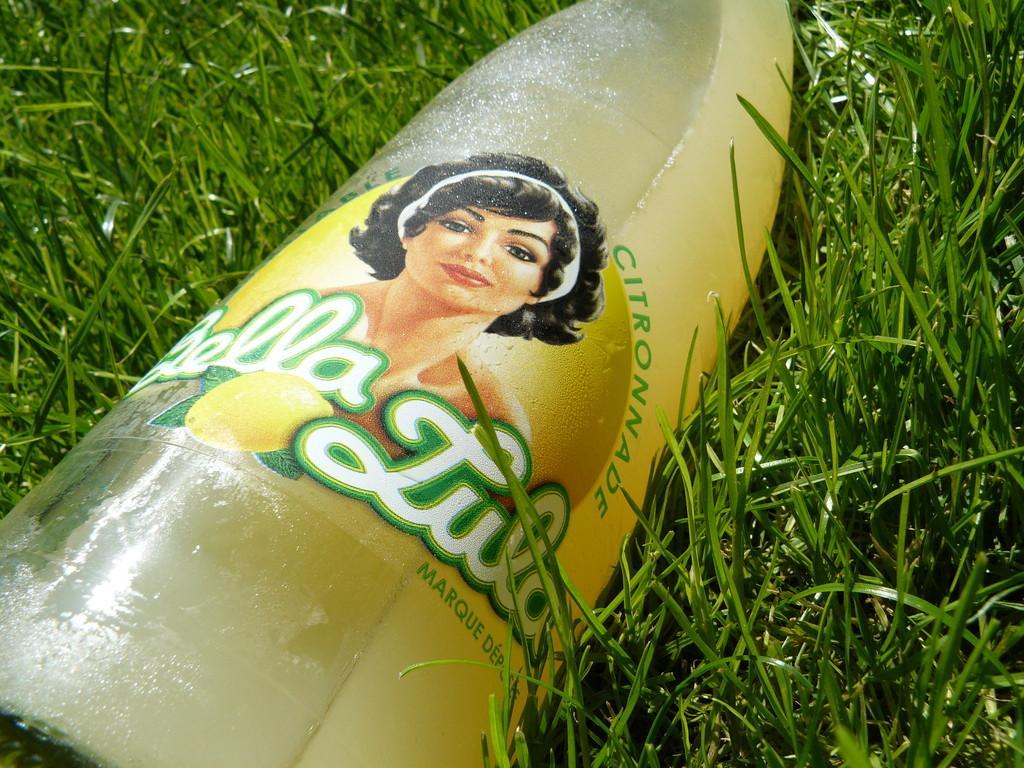Could you give a brief overview of what you see in this image? In this image, we can see a bottle on the grass. 